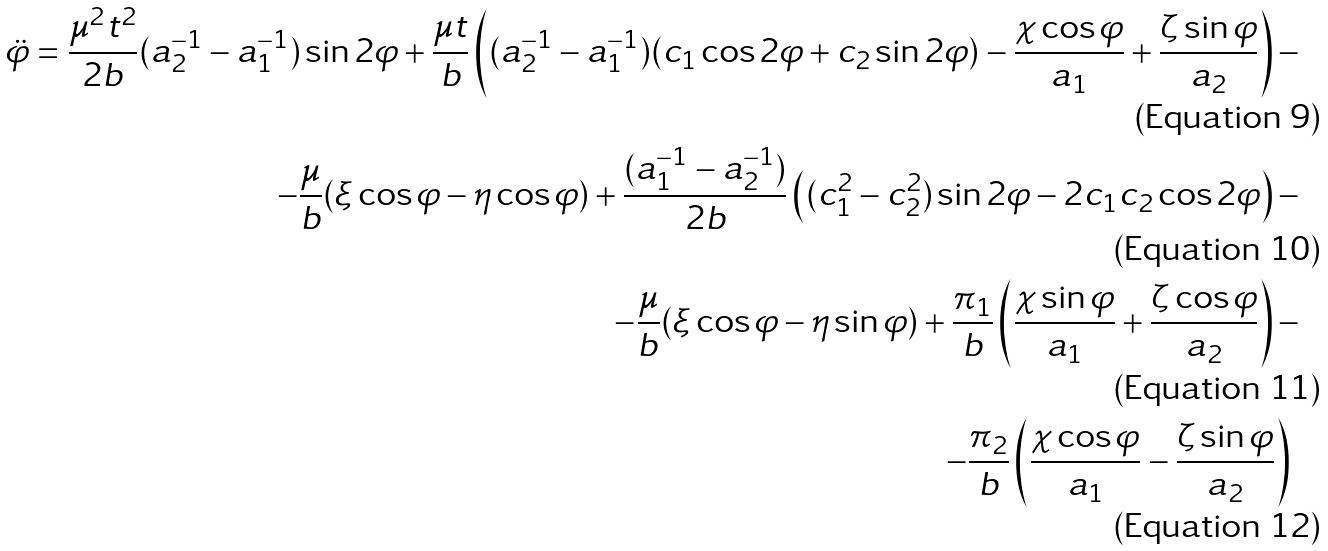Convert formula to latex. <formula><loc_0><loc_0><loc_500><loc_500>\ddot { \varphi } = \frac { \mu ^ { 2 } t ^ { 2 } } { 2 b } ( a _ { 2 } ^ { - 1 } - a _ { 1 } ^ { - 1 } ) \sin 2 \varphi + \frac { \mu t } { b } \left ( ( a ^ { - 1 } _ { 2 } - a _ { 1 } ^ { - 1 } ) ( c _ { 1 } \cos 2 \varphi + c _ { 2 } \sin 2 \varphi ) - \frac { \chi \cos \varphi } { a _ { 1 } } + \frac { \zeta \sin \varphi } { a _ { 2 } } \right ) - \\ - \frac { \mu } { b } ( \xi \cos \varphi - \eta \cos \varphi ) + \frac { ( a _ { 1 } ^ { - 1 } - a _ { 2 } ^ { - 1 } ) } { 2 b } \left ( ( c _ { 1 } ^ { 2 } - c _ { 2 } ^ { 2 } ) \sin 2 \varphi - 2 c _ { 1 } c _ { 2 } \cos 2 \varphi \right ) - \\ - \frac { \mu } { b } ( \xi \cos \varphi - \eta \sin \varphi ) + \frac { \pi _ { 1 } } { b } \left ( \frac { \chi \sin \varphi } { a _ { 1 } } + \frac { \zeta \cos \varphi } { a _ { 2 } } \right ) - \\ - \frac { \pi _ { 2 } } { b } \left ( \frac { \chi \cos \varphi } { a _ { 1 } } - \frac { \zeta \sin \varphi } { a _ { 2 } } \right ) \</formula> 